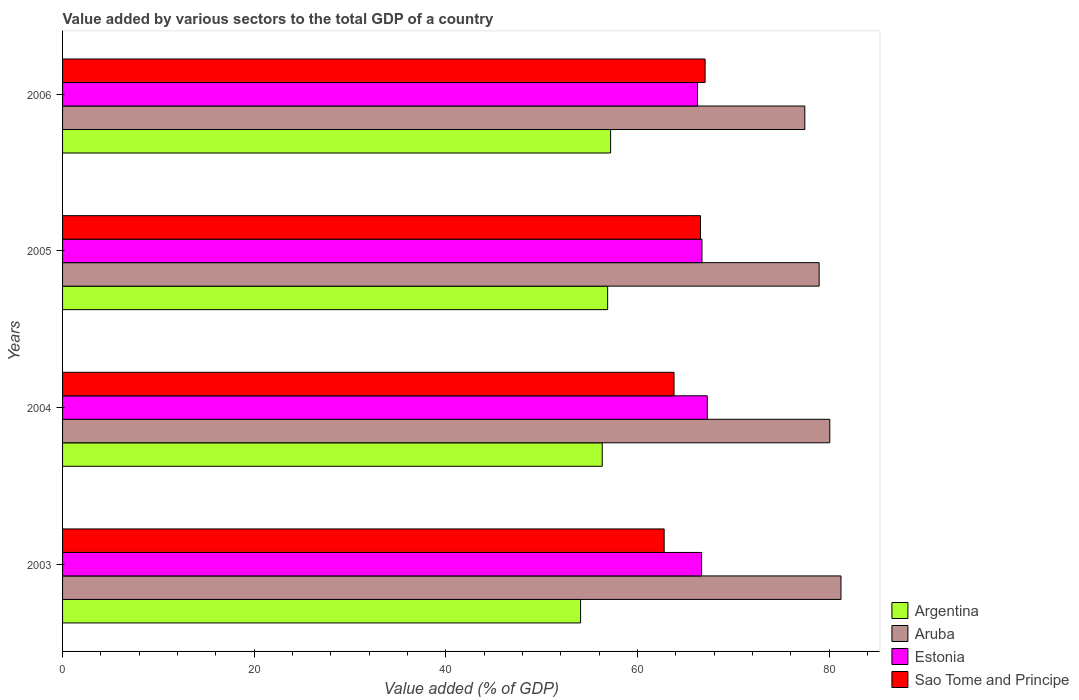Are the number of bars per tick equal to the number of legend labels?
Ensure brevity in your answer.  Yes. How many bars are there on the 2nd tick from the bottom?
Your answer should be very brief. 4. What is the label of the 4th group of bars from the top?
Make the answer very short. 2003. What is the value added by various sectors to the total GDP in Estonia in 2006?
Keep it short and to the point. 66.26. Across all years, what is the maximum value added by various sectors to the total GDP in Sao Tome and Principe?
Your response must be concise. 67.05. Across all years, what is the minimum value added by various sectors to the total GDP in Sao Tome and Principe?
Give a very brief answer. 62.78. In which year was the value added by various sectors to the total GDP in Sao Tome and Principe maximum?
Your answer should be very brief. 2006. In which year was the value added by various sectors to the total GDP in Sao Tome and Principe minimum?
Provide a short and direct response. 2003. What is the total value added by various sectors to the total GDP in Estonia in the graph?
Offer a terse response. 266.95. What is the difference between the value added by various sectors to the total GDP in Sao Tome and Principe in 2005 and that in 2006?
Your answer should be compact. -0.48. What is the difference between the value added by various sectors to the total GDP in Argentina in 2004 and the value added by various sectors to the total GDP in Aruba in 2003?
Offer a terse response. -24.91. What is the average value added by various sectors to the total GDP in Aruba per year?
Provide a succinct answer. 79.42. In the year 2006, what is the difference between the value added by various sectors to the total GDP in Aruba and value added by various sectors to the total GDP in Estonia?
Ensure brevity in your answer.  11.19. What is the ratio of the value added by various sectors to the total GDP in Sao Tome and Principe in 2004 to that in 2006?
Your answer should be very brief. 0.95. Is the value added by various sectors to the total GDP in Estonia in 2003 less than that in 2004?
Offer a terse response. Yes. What is the difference between the highest and the second highest value added by various sectors to the total GDP in Argentina?
Ensure brevity in your answer.  0.31. What is the difference between the highest and the lowest value added by various sectors to the total GDP in Estonia?
Keep it short and to the point. 1.02. In how many years, is the value added by various sectors to the total GDP in Sao Tome and Principe greater than the average value added by various sectors to the total GDP in Sao Tome and Principe taken over all years?
Make the answer very short. 2. Is it the case that in every year, the sum of the value added by various sectors to the total GDP in Argentina and value added by various sectors to the total GDP in Aruba is greater than the sum of value added by various sectors to the total GDP in Estonia and value added by various sectors to the total GDP in Sao Tome and Principe?
Offer a very short reply. Yes. What does the 3rd bar from the bottom in 2005 represents?
Keep it short and to the point. Estonia. Is it the case that in every year, the sum of the value added by various sectors to the total GDP in Argentina and value added by various sectors to the total GDP in Estonia is greater than the value added by various sectors to the total GDP in Aruba?
Ensure brevity in your answer.  Yes. How many bars are there?
Offer a terse response. 16. How many years are there in the graph?
Your answer should be compact. 4. What is the difference between two consecutive major ticks on the X-axis?
Make the answer very short. 20. Does the graph contain grids?
Make the answer very short. No. Where does the legend appear in the graph?
Provide a short and direct response. Bottom right. How many legend labels are there?
Provide a succinct answer. 4. How are the legend labels stacked?
Your answer should be very brief. Vertical. What is the title of the graph?
Offer a very short reply. Value added by various sectors to the total GDP of a country. What is the label or title of the X-axis?
Provide a short and direct response. Value added (% of GDP). What is the Value added (% of GDP) of Argentina in 2003?
Offer a very short reply. 54.06. What is the Value added (% of GDP) of Aruba in 2003?
Your answer should be very brief. 81.23. What is the Value added (% of GDP) in Estonia in 2003?
Provide a succinct answer. 66.68. What is the Value added (% of GDP) of Sao Tome and Principe in 2003?
Provide a short and direct response. 62.78. What is the Value added (% of GDP) of Argentina in 2004?
Offer a terse response. 56.31. What is the Value added (% of GDP) in Aruba in 2004?
Provide a succinct answer. 80.06. What is the Value added (% of GDP) in Estonia in 2004?
Provide a short and direct response. 67.28. What is the Value added (% of GDP) of Sao Tome and Principe in 2004?
Keep it short and to the point. 63.81. What is the Value added (% of GDP) of Argentina in 2005?
Give a very brief answer. 56.88. What is the Value added (% of GDP) in Aruba in 2005?
Keep it short and to the point. 78.95. What is the Value added (% of GDP) in Estonia in 2005?
Keep it short and to the point. 66.72. What is the Value added (% of GDP) of Sao Tome and Principe in 2005?
Your answer should be very brief. 66.57. What is the Value added (% of GDP) in Argentina in 2006?
Give a very brief answer. 57.19. What is the Value added (% of GDP) of Aruba in 2006?
Ensure brevity in your answer.  77.45. What is the Value added (% of GDP) in Estonia in 2006?
Your answer should be very brief. 66.26. What is the Value added (% of GDP) of Sao Tome and Principe in 2006?
Your answer should be compact. 67.05. Across all years, what is the maximum Value added (% of GDP) of Argentina?
Make the answer very short. 57.19. Across all years, what is the maximum Value added (% of GDP) in Aruba?
Offer a very short reply. 81.23. Across all years, what is the maximum Value added (% of GDP) in Estonia?
Ensure brevity in your answer.  67.28. Across all years, what is the maximum Value added (% of GDP) in Sao Tome and Principe?
Provide a short and direct response. 67.05. Across all years, what is the minimum Value added (% of GDP) in Argentina?
Your answer should be very brief. 54.06. Across all years, what is the minimum Value added (% of GDP) in Aruba?
Make the answer very short. 77.45. Across all years, what is the minimum Value added (% of GDP) in Estonia?
Offer a terse response. 66.26. Across all years, what is the minimum Value added (% of GDP) of Sao Tome and Principe?
Ensure brevity in your answer.  62.78. What is the total Value added (% of GDP) in Argentina in the graph?
Your response must be concise. 224.44. What is the total Value added (% of GDP) of Aruba in the graph?
Keep it short and to the point. 317.69. What is the total Value added (% of GDP) in Estonia in the graph?
Your answer should be very brief. 266.95. What is the total Value added (% of GDP) in Sao Tome and Principe in the graph?
Your answer should be very brief. 260.2. What is the difference between the Value added (% of GDP) in Argentina in 2003 and that in 2004?
Keep it short and to the point. -2.26. What is the difference between the Value added (% of GDP) in Aruba in 2003 and that in 2004?
Provide a short and direct response. 1.17. What is the difference between the Value added (% of GDP) of Estonia in 2003 and that in 2004?
Provide a succinct answer. -0.59. What is the difference between the Value added (% of GDP) in Sao Tome and Principe in 2003 and that in 2004?
Give a very brief answer. -1.03. What is the difference between the Value added (% of GDP) of Argentina in 2003 and that in 2005?
Provide a succinct answer. -2.82. What is the difference between the Value added (% of GDP) of Aruba in 2003 and that in 2005?
Provide a succinct answer. 2.28. What is the difference between the Value added (% of GDP) of Estonia in 2003 and that in 2005?
Provide a short and direct response. -0.04. What is the difference between the Value added (% of GDP) of Sao Tome and Principe in 2003 and that in 2005?
Your response must be concise. -3.79. What is the difference between the Value added (% of GDP) of Argentina in 2003 and that in 2006?
Offer a terse response. -3.14. What is the difference between the Value added (% of GDP) of Aruba in 2003 and that in 2006?
Give a very brief answer. 3.77. What is the difference between the Value added (% of GDP) in Estonia in 2003 and that in 2006?
Ensure brevity in your answer.  0.42. What is the difference between the Value added (% of GDP) of Sao Tome and Principe in 2003 and that in 2006?
Offer a terse response. -4.27. What is the difference between the Value added (% of GDP) of Argentina in 2004 and that in 2005?
Ensure brevity in your answer.  -0.56. What is the difference between the Value added (% of GDP) of Aruba in 2004 and that in 2005?
Your response must be concise. 1.11. What is the difference between the Value added (% of GDP) of Estonia in 2004 and that in 2005?
Your answer should be compact. 0.55. What is the difference between the Value added (% of GDP) of Sao Tome and Principe in 2004 and that in 2005?
Give a very brief answer. -2.76. What is the difference between the Value added (% of GDP) in Argentina in 2004 and that in 2006?
Offer a terse response. -0.88. What is the difference between the Value added (% of GDP) of Aruba in 2004 and that in 2006?
Your answer should be compact. 2.61. What is the difference between the Value added (% of GDP) in Estonia in 2004 and that in 2006?
Keep it short and to the point. 1.02. What is the difference between the Value added (% of GDP) of Sao Tome and Principe in 2004 and that in 2006?
Your answer should be compact. -3.24. What is the difference between the Value added (% of GDP) of Argentina in 2005 and that in 2006?
Ensure brevity in your answer.  -0.31. What is the difference between the Value added (% of GDP) of Aruba in 2005 and that in 2006?
Provide a short and direct response. 1.5. What is the difference between the Value added (% of GDP) of Estonia in 2005 and that in 2006?
Your response must be concise. 0.46. What is the difference between the Value added (% of GDP) in Sao Tome and Principe in 2005 and that in 2006?
Provide a succinct answer. -0.48. What is the difference between the Value added (% of GDP) of Argentina in 2003 and the Value added (% of GDP) of Aruba in 2004?
Your response must be concise. -26. What is the difference between the Value added (% of GDP) in Argentina in 2003 and the Value added (% of GDP) in Estonia in 2004?
Your answer should be compact. -13.22. What is the difference between the Value added (% of GDP) in Argentina in 2003 and the Value added (% of GDP) in Sao Tome and Principe in 2004?
Give a very brief answer. -9.75. What is the difference between the Value added (% of GDP) in Aruba in 2003 and the Value added (% of GDP) in Estonia in 2004?
Your answer should be very brief. 13.95. What is the difference between the Value added (% of GDP) in Aruba in 2003 and the Value added (% of GDP) in Sao Tome and Principe in 2004?
Your answer should be compact. 17.42. What is the difference between the Value added (% of GDP) of Estonia in 2003 and the Value added (% of GDP) of Sao Tome and Principe in 2004?
Offer a terse response. 2.88. What is the difference between the Value added (% of GDP) in Argentina in 2003 and the Value added (% of GDP) in Aruba in 2005?
Your answer should be very brief. -24.89. What is the difference between the Value added (% of GDP) in Argentina in 2003 and the Value added (% of GDP) in Estonia in 2005?
Provide a succinct answer. -12.67. What is the difference between the Value added (% of GDP) in Argentina in 2003 and the Value added (% of GDP) in Sao Tome and Principe in 2005?
Give a very brief answer. -12.52. What is the difference between the Value added (% of GDP) in Aruba in 2003 and the Value added (% of GDP) in Estonia in 2005?
Give a very brief answer. 14.5. What is the difference between the Value added (% of GDP) in Aruba in 2003 and the Value added (% of GDP) in Sao Tome and Principe in 2005?
Make the answer very short. 14.66. What is the difference between the Value added (% of GDP) of Estonia in 2003 and the Value added (% of GDP) of Sao Tome and Principe in 2005?
Offer a terse response. 0.11. What is the difference between the Value added (% of GDP) of Argentina in 2003 and the Value added (% of GDP) of Aruba in 2006?
Offer a terse response. -23.4. What is the difference between the Value added (% of GDP) in Argentina in 2003 and the Value added (% of GDP) in Estonia in 2006?
Make the answer very short. -12.21. What is the difference between the Value added (% of GDP) in Argentina in 2003 and the Value added (% of GDP) in Sao Tome and Principe in 2006?
Give a very brief answer. -12.99. What is the difference between the Value added (% of GDP) of Aruba in 2003 and the Value added (% of GDP) of Estonia in 2006?
Your answer should be very brief. 14.96. What is the difference between the Value added (% of GDP) of Aruba in 2003 and the Value added (% of GDP) of Sao Tome and Principe in 2006?
Your answer should be compact. 14.18. What is the difference between the Value added (% of GDP) of Estonia in 2003 and the Value added (% of GDP) of Sao Tome and Principe in 2006?
Offer a terse response. -0.36. What is the difference between the Value added (% of GDP) in Argentina in 2004 and the Value added (% of GDP) in Aruba in 2005?
Ensure brevity in your answer.  -22.63. What is the difference between the Value added (% of GDP) in Argentina in 2004 and the Value added (% of GDP) in Estonia in 2005?
Your answer should be very brief. -10.41. What is the difference between the Value added (% of GDP) of Argentina in 2004 and the Value added (% of GDP) of Sao Tome and Principe in 2005?
Your answer should be compact. -10.26. What is the difference between the Value added (% of GDP) of Aruba in 2004 and the Value added (% of GDP) of Estonia in 2005?
Give a very brief answer. 13.34. What is the difference between the Value added (% of GDP) in Aruba in 2004 and the Value added (% of GDP) in Sao Tome and Principe in 2005?
Provide a succinct answer. 13.49. What is the difference between the Value added (% of GDP) in Estonia in 2004 and the Value added (% of GDP) in Sao Tome and Principe in 2005?
Offer a terse response. 0.71. What is the difference between the Value added (% of GDP) in Argentina in 2004 and the Value added (% of GDP) in Aruba in 2006?
Give a very brief answer. -21.14. What is the difference between the Value added (% of GDP) in Argentina in 2004 and the Value added (% of GDP) in Estonia in 2006?
Offer a very short reply. -9.95. What is the difference between the Value added (% of GDP) of Argentina in 2004 and the Value added (% of GDP) of Sao Tome and Principe in 2006?
Give a very brief answer. -10.73. What is the difference between the Value added (% of GDP) in Aruba in 2004 and the Value added (% of GDP) in Estonia in 2006?
Offer a terse response. 13.8. What is the difference between the Value added (% of GDP) in Aruba in 2004 and the Value added (% of GDP) in Sao Tome and Principe in 2006?
Your answer should be compact. 13.01. What is the difference between the Value added (% of GDP) in Estonia in 2004 and the Value added (% of GDP) in Sao Tome and Principe in 2006?
Your answer should be compact. 0.23. What is the difference between the Value added (% of GDP) of Argentina in 2005 and the Value added (% of GDP) of Aruba in 2006?
Keep it short and to the point. -20.57. What is the difference between the Value added (% of GDP) of Argentina in 2005 and the Value added (% of GDP) of Estonia in 2006?
Ensure brevity in your answer.  -9.38. What is the difference between the Value added (% of GDP) in Argentina in 2005 and the Value added (% of GDP) in Sao Tome and Principe in 2006?
Your response must be concise. -10.17. What is the difference between the Value added (% of GDP) of Aruba in 2005 and the Value added (% of GDP) of Estonia in 2006?
Give a very brief answer. 12.69. What is the difference between the Value added (% of GDP) in Aruba in 2005 and the Value added (% of GDP) in Sao Tome and Principe in 2006?
Keep it short and to the point. 11.9. What is the difference between the Value added (% of GDP) of Estonia in 2005 and the Value added (% of GDP) of Sao Tome and Principe in 2006?
Provide a short and direct response. -0.32. What is the average Value added (% of GDP) of Argentina per year?
Keep it short and to the point. 56.11. What is the average Value added (% of GDP) of Aruba per year?
Ensure brevity in your answer.  79.42. What is the average Value added (% of GDP) in Estonia per year?
Your response must be concise. 66.74. What is the average Value added (% of GDP) in Sao Tome and Principe per year?
Your response must be concise. 65.05. In the year 2003, what is the difference between the Value added (% of GDP) in Argentina and Value added (% of GDP) in Aruba?
Make the answer very short. -27.17. In the year 2003, what is the difference between the Value added (% of GDP) of Argentina and Value added (% of GDP) of Estonia?
Offer a very short reply. -12.63. In the year 2003, what is the difference between the Value added (% of GDP) in Argentina and Value added (% of GDP) in Sao Tome and Principe?
Provide a short and direct response. -8.72. In the year 2003, what is the difference between the Value added (% of GDP) in Aruba and Value added (% of GDP) in Estonia?
Your answer should be very brief. 14.54. In the year 2003, what is the difference between the Value added (% of GDP) of Aruba and Value added (% of GDP) of Sao Tome and Principe?
Your response must be concise. 18.45. In the year 2003, what is the difference between the Value added (% of GDP) in Estonia and Value added (% of GDP) in Sao Tome and Principe?
Make the answer very short. 3.91. In the year 2004, what is the difference between the Value added (% of GDP) in Argentina and Value added (% of GDP) in Aruba?
Your answer should be compact. -23.75. In the year 2004, what is the difference between the Value added (% of GDP) of Argentina and Value added (% of GDP) of Estonia?
Offer a very short reply. -10.96. In the year 2004, what is the difference between the Value added (% of GDP) in Argentina and Value added (% of GDP) in Sao Tome and Principe?
Offer a very short reply. -7.49. In the year 2004, what is the difference between the Value added (% of GDP) of Aruba and Value added (% of GDP) of Estonia?
Offer a very short reply. 12.78. In the year 2004, what is the difference between the Value added (% of GDP) in Aruba and Value added (% of GDP) in Sao Tome and Principe?
Your answer should be very brief. 16.25. In the year 2004, what is the difference between the Value added (% of GDP) in Estonia and Value added (% of GDP) in Sao Tome and Principe?
Keep it short and to the point. 3.47. In the year 2005, what is the difference between the Value added (% of GDP) of Argentina and Value added (% of GDP) of Aruba?
Provide a succinct answer. -22.07. In the year 2005, what is the difference between the Value added (% of GDP) of Argentina and Value added (% of GDP) of Estonia?
Offer a terse response. -9.85. In the year 2005, what is the difference between the Value added (% of GDP) in Argentina and Value added (% of GDP) in Sao Tome and Principe?
Give a very brief answer. -9.69. In the year 2005, what is the difference between the Value added (% of GDP) of Aruba and Value added (% of GDP) of Estonia?
Ensure brevity in your answer.  12.23. In the year 2005, what is the difference between the Value added (% of GDP) of Aruba and Value added (% of GDP) of Sao Tome and Principe?
Offer a terse response. 12.38. In the year 2005, what is the difference between the Value added (% of GDP) in Estonia and Value added (% of GDP) in Sao Tome and Principe?
Your answer should be very brief. 0.15. In the year 2006, what is the difference between the Value added (% of GDP) in Argentina and Value added (% of GDP) in Aruba?
Keep it short and to the point. -20.26. In the year 2006, what is the difference between the Value added (% of GDP) of Argentina and Value added (% of GDP) of Estonia?
Offer a very short reply. -9.07. In the year 2006, what is the difference between the Value added (% of GDP) of Argentina and Value added (% of GDP) of Sao Tome and Principe?
Ensure brevity in your answer.  -9.86. In the year 2006, what is the difference between the Value added (% of GDP) in Aruba and Value added (% of GDP) in Estonia?
Your answer should be compact. 11.19. In the year 2006, what is the difference between the Value added (% of GDP) in Aruba and Value added (% of GDP) in Sao Tome and Principe?
Your answer should be very brief. 10.41. In the year 2006, what is the difference between the Value added (% of GDP) in Estonia and Value added (% of GDP) in Sao Tome and Principe?
Provide a succinct answer. -0.79. What is the ratio of the Value added (% of GDP) of Argentina in 2003 to that in 2004?
Offer a very short reply. 0.96. What is the ratio of the Value added (% of GDP) in Aruba in 2003 to that in 2004?
Keep it short and to the point. 1.01. What is the ratio of the Value added (% of GDP) in Estonia in 2003 to that in 2004?
Your answer should be very brief. 0.99. What is the ratio of the Value added (% of GDP) of Sao Tome and Principe in 2003 to that in 2004?
Provide a short and direct response. 0.98. What is the ratio of the Value added (% of GDP) in Argentina in 2003 to that in 2005?
Provide a succinct answer. 0.95. What is the ratio of the Value added (% of GDP) in Aruba in 2003 to that in 2005?
Ensure brevity in your answer.  1.03. What is the ratio of the Value added (% of GDP) in Sao Tome and Principe in 2003 to that in 2005?
Offer a very short reply. 0.94. What is the ratio of the Value added (% of GDP) in Argentina in 2003 to that in 2006?
Your answer should be very brief. 0.95. What is the ratio of the Value added (% of GDP) of Aruba in 2003 to that in 2006?
Give a very brief answer. 1.05. What is the ratio of the Value added (% of GDP) in Estonia in 2003 to that in 2006?
Provide a succinct answer. 1.01. What is the ratio of the Value added (% of GDP) in Sao Tome and Principe in 2003 to that in 2006?
Your answer should be compact. 0.94. What is the ratio of the Value added (% of GDP) in Aruba in 2004 to that in 2005?
Your response must be concise. 1.01. What is the ratio of the Value added (% of GDP) of Estonia in 2004 to that in 2005?
Your answer should be very brief. 1.01. What is the ratio of the Value added (% of GDP) in Sao Tome and Principe in 2004 to that in 2005?
Your answer should be very brief. 0.96. What is the ratio of the Value added (% of GDP) of Argentina in 2004 to that in 2006?
Offer a very short reply. 0.98. What is the ratio of the Value added (% of GDP) in Aruba in 2004 to that in 2006?
Your response must be concise. 1.03. What is the ratio of the Value added (% of GDP) in Estonia in 2004 to that in 2006?
Provide a short and direct response. 1.02. What is the ratio of the Value added (% of GDP) of Sao Tome and Principe in 2004 to that in 2006?
Your response must be concise. 0.95. What is the ratio of the Value added (% of GDP) in Argentina in 2005 to that in 2006?
Offer a terse response. 0.99. What is the ratio of the Value added (% of GDP) in Aruba in 2005 to that in 2006?
Your response must be concise. 1.02. What is the difference between the highest and the second highest Value added (% of GDP) of Argentina?
Give a very brief answer. 0.31. What is the difference between the highest and the second highest Value added (% of GDP) of Aruba?
Your response must be concise. 1.17. What is the difference between the highest and the second highest Value added (% of GDP) in Estonia?
Provide a succinct answer. 0.55. What is the difference between the highest and the second highest Value added (% of GDP) of Sao Tome and Principe?
Offer a terse response. 0.48. What is the difference between the highest and the lowest Value added (% of GDP) in Argentina?
Keep it short and to the point. 3.14. What is the difference between the highest and the lowest Value added (% of GDP) in Aruba?
Your answer should be very brief. 3.77. What is the difference between the highest and the lowest Value added (% of GDP) in Estonia?
Your response must be concise. 1.02. What is the difference between the highest and the lowest Value added (% of GDP) in Sao Tome and Principe?
Offer a terse response. 4.27. 